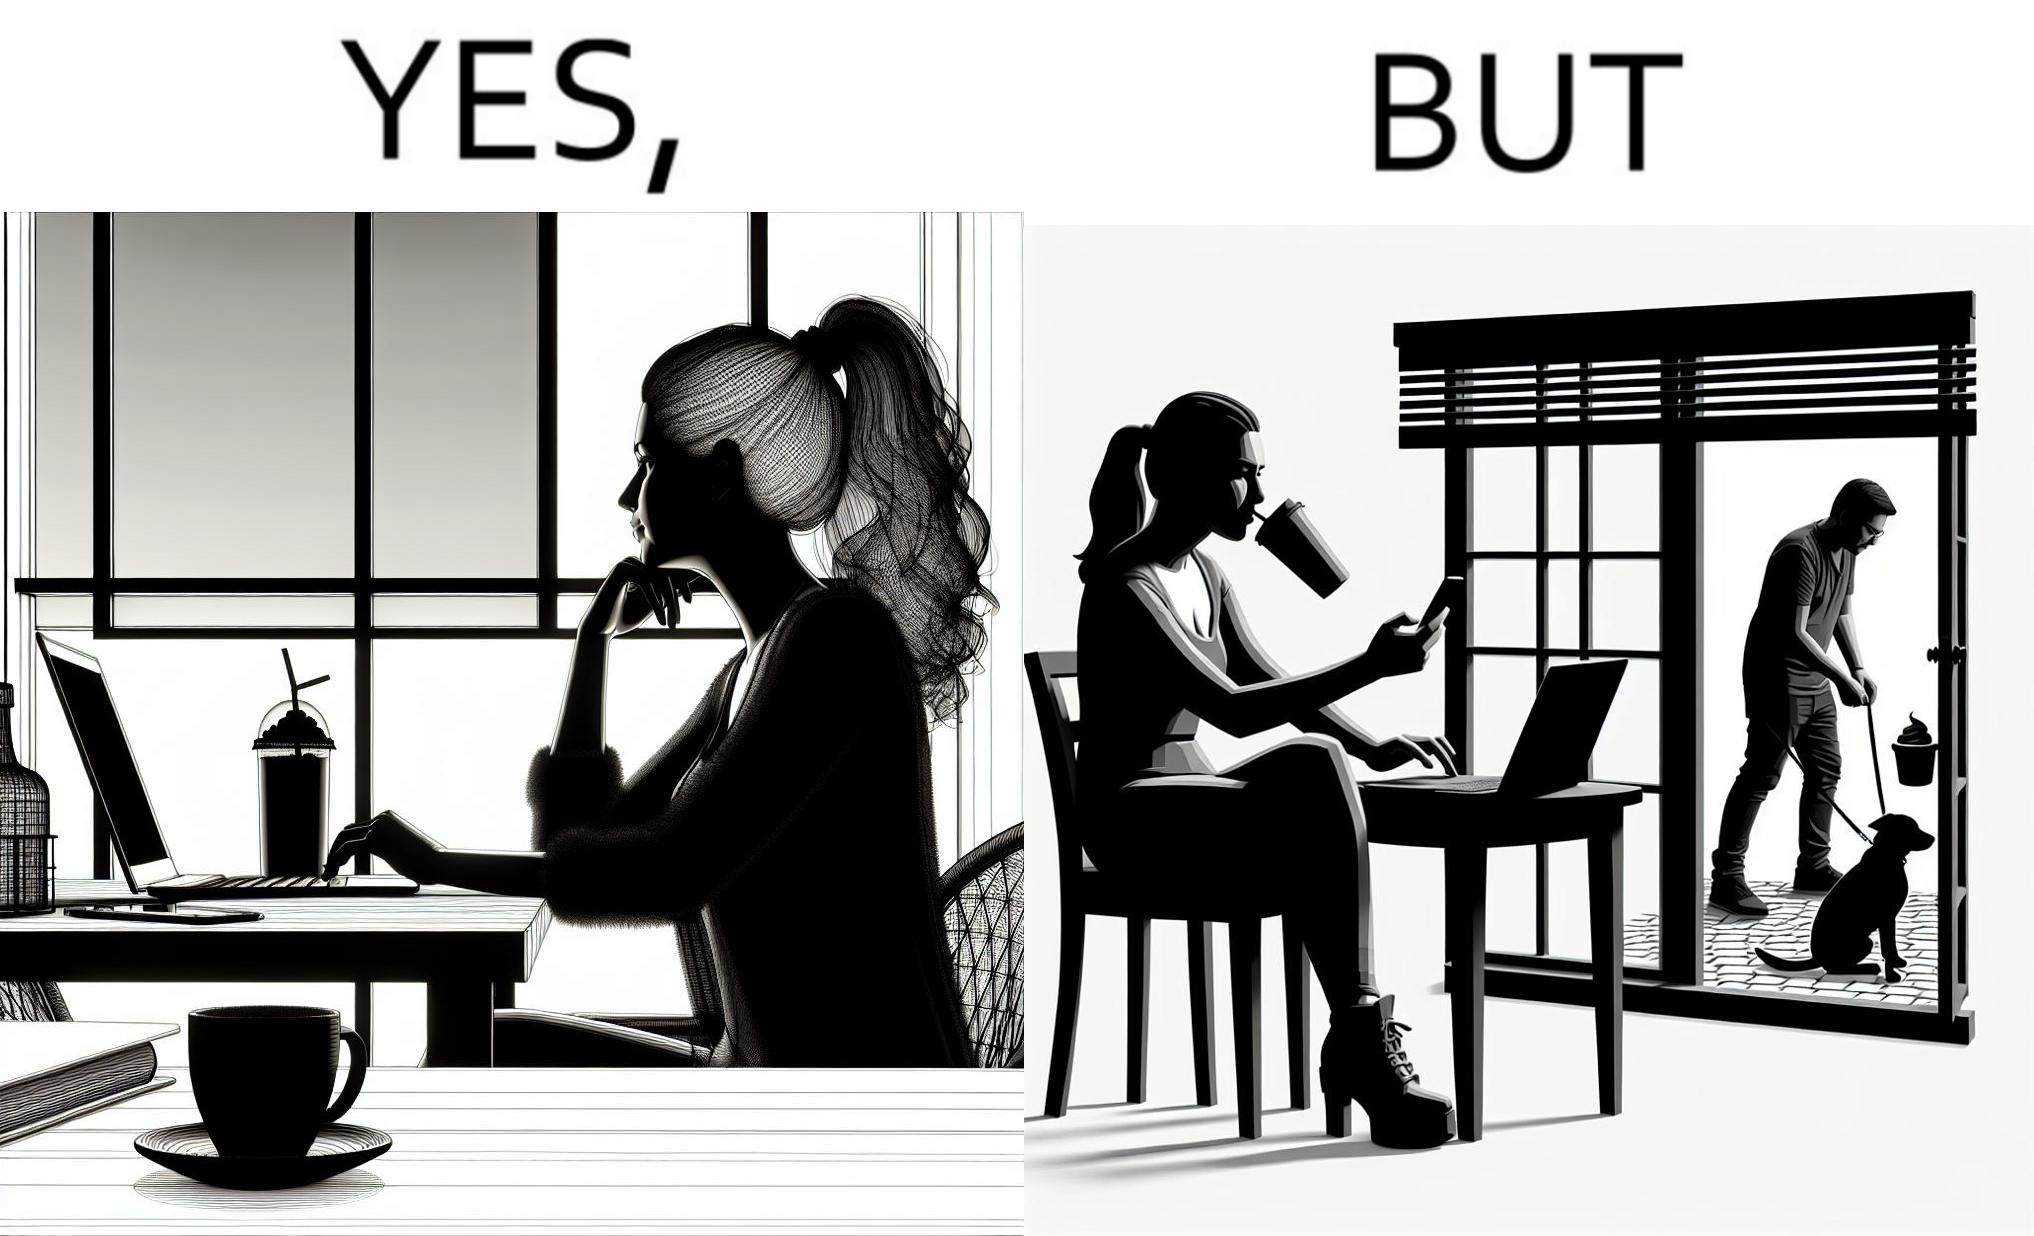Describe the content of this image. The image is ironic, because in the first image the woman is seen as enjoying the view but in the second image the same woman is seen as looking at a pooping dog 